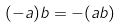Convert formula to latex. <formula><loc_0><loc_0><loc_500><loc_500>( - a ) b = - ( a b )</formula> 